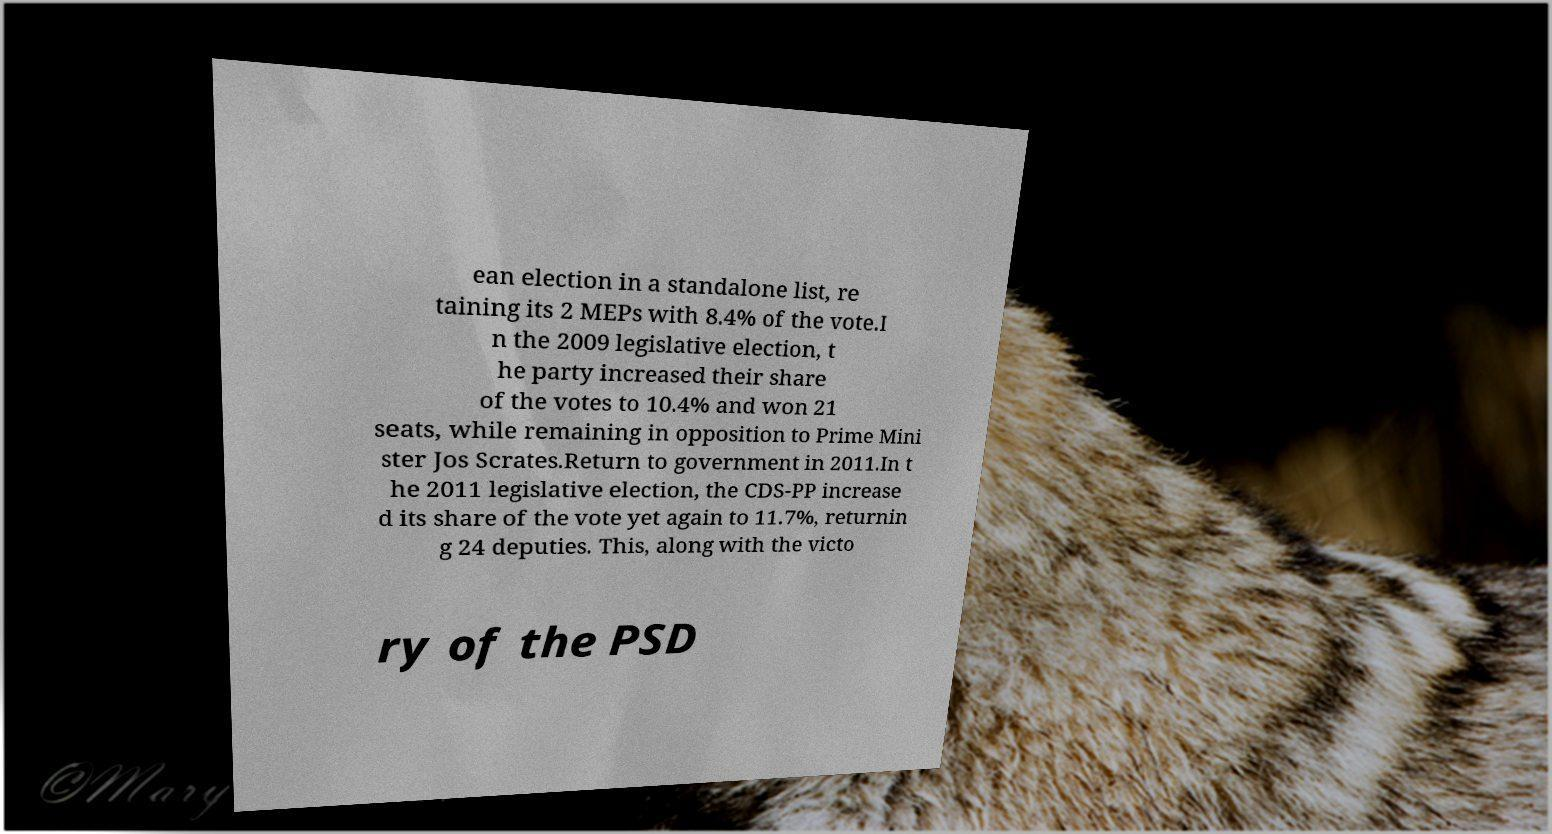Could you extract and type out the text from this image? ean election in a standalone list, re taining its 2 MEPs with 8.4% of the vote.I n the 2009 legislative election, t he party increased their share of the votes to 10.4% and won 21 seats, while remaining in opposition to Prime Mini ster Jos Scrates.Return to government in 2011.In t he 2011 legislative election, the CDS-PP increase d its share of the vote yet again to 11.7%, returnin g 24 deputies. This, along with the victo ry of the PSD 